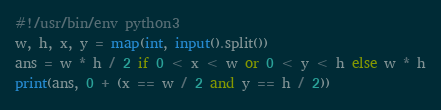Convert code to text. <code><loc_0><loc_0><loc_500><loc_500><_Python_>#!/usr/bin/env python3
w, h, x, y = map(int, input().split())
ans = w * h / 2 if 0 < x < w or 0 < y < h else w * h
print(ans, 0 + (x == w / 2 and y == h / 2))
</code> 